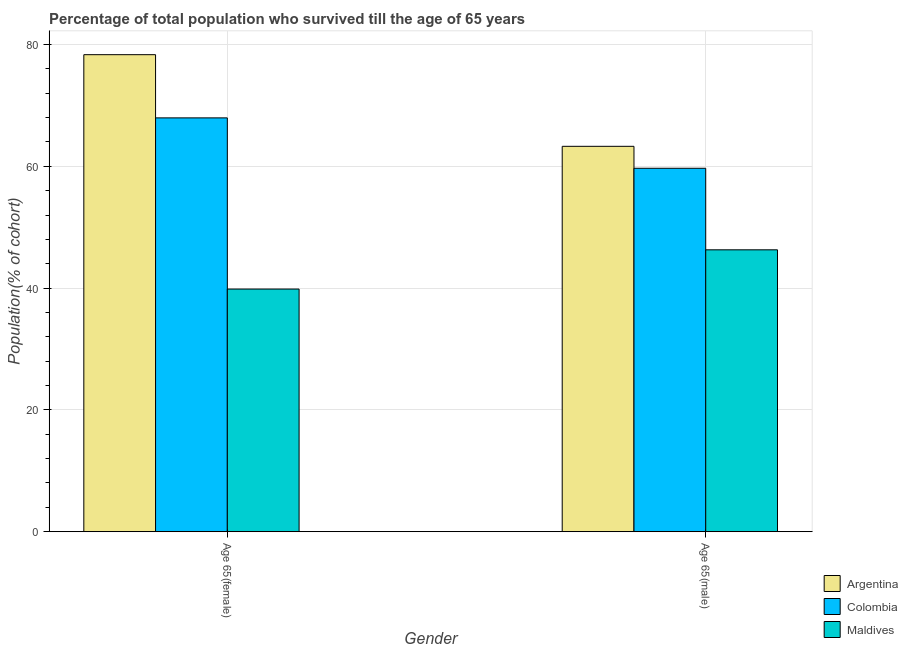How many groups of bars are there?
Provide a short and direct response. 2. How many bars are there on the 2nd tick from the right?
Your answer should be very brief. 3. What is the label of the 2nd group of bars from the left?
Offer a terse response. Age 65(male). What is the percentage of male population who survived till age of 65 in Colombia?
Your response must be concise. 59.67. Across all countries, what is the maximum percentage of male population who survived till age of 65?
Ensure brevity in your answer.  63.28. Across all countries, what is the minimum percentage of female population who survived till age of 65?
Keep it short and to the point. 39.84. In which country was the percentage of female population who survived till age of 65 maximum?
Offer a terse response. Argentina. In which country was the percentage of male population who survived till age of 65 minimum?
Offer a terse response. Maldives. What is the total percentage of male population who survived till age of 65 in the graph?
Offer a terse response. 169.23. What is the difference between the percentage of female population who survived till age of 65 in Argentina and that in Maldives?
Keep it short and to the point. 38.48. What is the difference between the percentage of male population who survived till age of 65 in Colombia and the percentage of female population who survived till age of 65 in Maldives?
Give a very brief answer. 19.83. What is the average percentage of female population who survived till age of 65 per country?
Your response must be concise. 62.04. What is the difference between the percentage of female population who survived till age of 65 and percentage of male population who survived till age of 65 in Maldives?
Your answer should be compact. -6.44. What is the ratio of the percentage of female population who survived till age of 65 in Colombia to that in Maldives?
Offer a very short reply. 1.71. What does the 3rd bar from the left in Age 65(male) represents?
Provide a succinct answer. Maldives. What does the 1st bar from the right in Age 65(male) represents?
Your answer should be compact. Maldives. How many countries are there in the graph?
Offer a very short reply. 3. What is the difference between two consecutive major ticks on the Y-axis?
Give a very brief answer. 20. Are the values on the major ticks of Y-axis written in scientific E-notation?
Make the answer very short. No. Does the graph contain any zero values?
Provide a short and direct response. No. Does the graph contain grids?
Ensure brevity in your answer.  Yes. Where does the legend appear in the graph?
Your response must be concise. Bottom right. How many legend labels are there?
Provide a short and direct response. 3. What is the title of the graph?
Give a very brief answer. Percentage of total population who survived till the age of 65 years. Does "Ghana" appear as one of the legend labels in the graph?
Give a very brief answer. No. What is the label or title of the Y-axis?
Keep it short and to the point. Population(% of cohort). What is the Population(% of cohort) in Argentina in Age 65(female)?
Offer a terse response. 78.33. What is the Population(% of cohort) of Colombia in Age 65(female)?
Your answer should be compact. 67.95. What is the Population(% of cohort) in Maldives in Age 65(female)?
Give a very brief answer. 39.84. What is the Population(% of cohort) in Argentina in Age 65(male)?
Your answer should be very brief. 63.28. What is the Population(% of cohort) of Colombia in Age 65(male)?
Your answer should be compact. 59.67. What is the Population(% of cohort) in Maldives in Age 65(male)?
Keep it short and to the point. 46.28. Across all Gender, what is the maximum Population(% of cohort) in Argentina?
Offer a terse response. 78.33. Across all Gender, what is the maximum Population(% of cohort) of Colombia?
Your response must be concise. 67.95. Across all Gender, what is the maximum Population(% of cohort) of Maldives?
Provide a short and direct response. 46.28. Across all Gender, what is the minimum Population(% of cohort) in Argentina?
Make the answer very short. 63.28. Across all Gender, what is the minimum Population(% of cohort) in Colombia?
Your answer should be compact. 59.67. Across all Gender, what is the minimum Population(% of cohort) of Maldives?
Offer a very short reply. 39.84. What is the total Population(% of cohort) in Argentina in the graph?
Provide a short and direct response. 141.6. What is the total Population(% of cohort) of Colombia in the graph?
Provide a short and direct response. 127.62. What is the total Population(% of cohort) of Maldives in the graph?
Your response must be concise. 86.13. What is the difference between the Population(% of cohort) of Argentina in Age 65(female) and that in Age 65(male)?
Your answer should be very brief. 15.05. What is the difference between the Population(% of cohort) in Colombia in Age 65(female) and that in Age 65(male)?
Offer a terse response. 8.28. What is the difference between the Population(% of cohort) in Maldives in Age 65(female) and that in Age 65(male)?
Provide a succinct answer. -6.44. What is the difference between the Population(% of cohort) in Argentina in Age 65(female) and the Population(% of cohort) in Colombia in Age 65(male)?
Your answer should be very brief. 18.65. What is the difference between the Population(% of cohort) of Argentina in Age 65(female) and the Population(% of cohort) of Maldives in Age 65(male)?
Give a very brief answer. 32.04. What is the difference between the Population(% of cohort) in Colombia in Age 65(female) and the Population(% of cohort) in Maldives in Age 65(male)?
Give a very brief answer. 21.66. What is the average Population(% of cohort) in Argentina per Gender?
Make the answer very short. 70.8. What is the average Population(% of cohort) in Colombia per Gender?
Ensure brevity in your answer.  63.81. What is the average Population(% of cohort) in Maldives per Gender?
Keep it short and to the point. 43.06. What is the difference between the Population(% of cohort) in Argentina and Population(% of cohort) in Colombia in Age 65(female)?
Offer a terse response. 10.38. What is the difference between the Population(% of cohort) of Argentina and Population(% of cohort) of Maldives in Age 65(female)?
Your answer should be very brief. 38.48. What is the difference between the Population(% of cohort) of Colombia and Population(% of cohort) of Maldives in Age 65(female)?
Offer a very short reply. 28.11. What is the difference between the Population(% of cohort) in Argentina and Population(% of cohort) in Colombia in Age 65(male)?
Offer a terse response. 3.61. What is the difference between the Population(% of cohort) in Argentina and Population(% of cohort) in Maldives in Age 65(male)?
Your answer should be compact. 16.99. What is the difference between the Population(% of cohort) in Colombia and Population(% of cohort) in Maldives in Age 65(male)?
Offer a terse response. 13.39. What is the ratio of the Population(% of cohort) of Argentina in Age 65(female) to that in Age 65(male)?
Provide a succinct answer. 1.24. What is the ratio of the Population(% of cohort) of Colombia in Age 65(female) to that in Age 65(male)?
Provide a short and direct response. 1.14. What is the ratio of the Population(% of cohort) in Maldives in Age 65(female) to that in Age 65(male)?
Offer a terse response. 0.86. What is the difference between the highest and the second highest Population(% of cohort) in Argentina?
Offer a terse response. 15.05. What is the difference between the highest and the second highest Population(% of cohort) of Colombia?
Offer a very short reply. 8.28. What is the difference between the highest and the second highest Population(% of cohort) of Maldives?
Make the answer very short. 6.44. What is the difference between the highest and the lowest Population(% of cohort) of Argentina?
Ensure brevity in your answer.  15.05. What is the difference between the highest and the lowest Population(% of cohort) in Colombia?
Provide a short and direct response. 8.28. What is the difference between the highest and the lowest Population(% of cohort) of Maldives?
Your answer should be very brief. 6.44. 